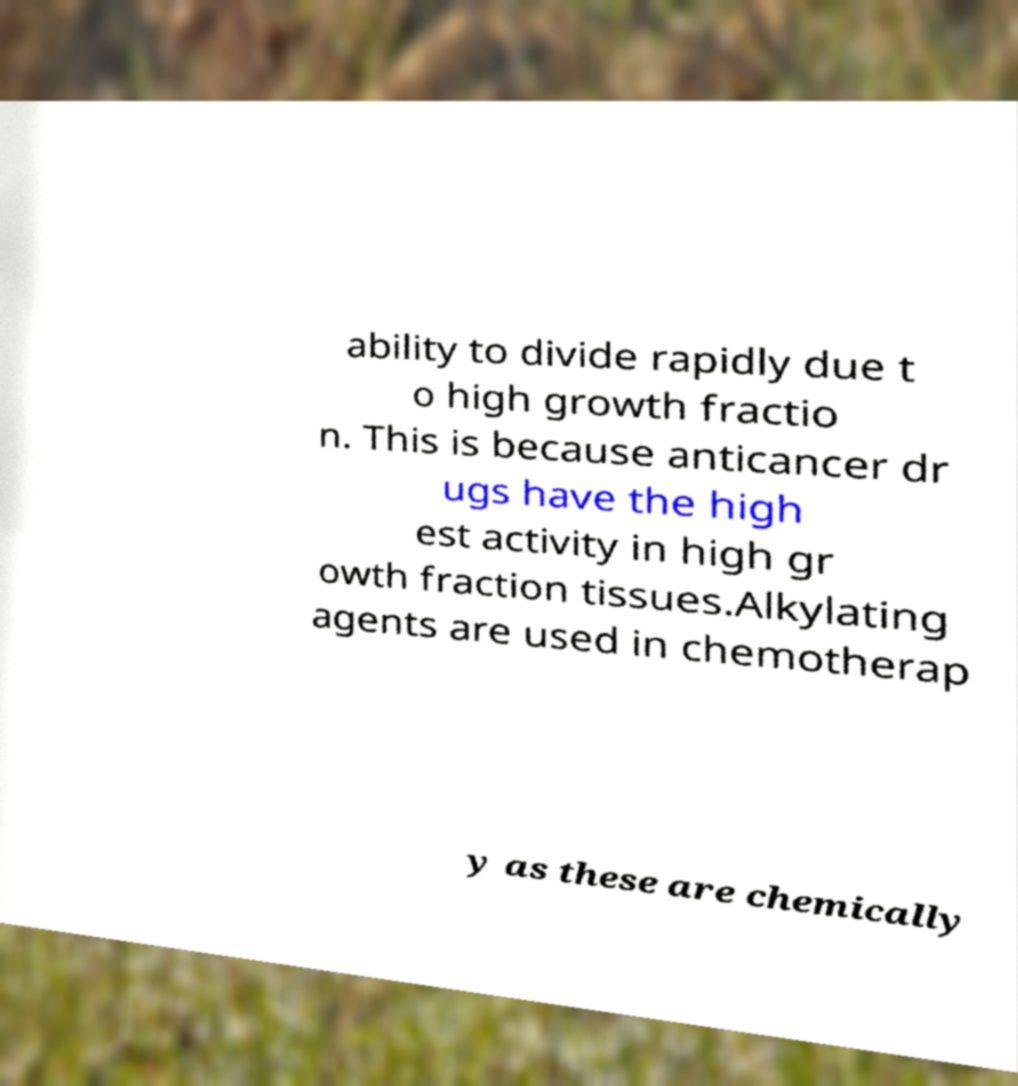I need the written content from this picture converted into text. Can you do that? ability to divide rapidly due t o high growth fractio n. This is because anticancer dr ugs have the high est activity in high gr owth fraction tissues.Alkylating agents are used in chemotherap y as these are chemically 